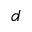<formula> <loc_0><loc_0><loc_500><loc_500>d</formula> 